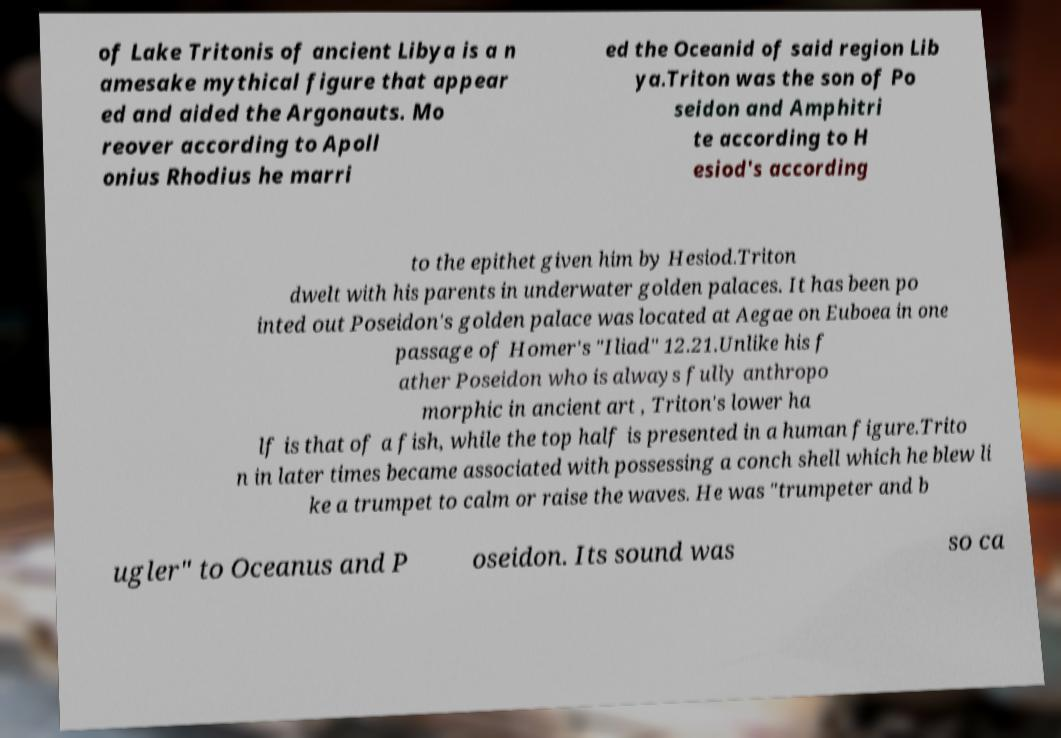Can you accurately transcribe the text from the provided image for me? of Lake Tritonis of ancient Libya is a n amesake mythical figure that appear ed and aided the Argonauts. Mo reover according to Apoll onius Rhodius he marri ed the Oceanid of said region Lib ya.Triton was the son of Po seidon and Amphitri te according to H esiod's according to the epithet given him by Hesiod.Triton dwelt with his parents in underwater golden palaces. It has been po inted out Poseidon's golden palace was located at Aegae on Euboea in one passage of Homer's "Iliad" 12.21.Unlike his f ather Poseidon who is always fully anthropo morphic in ancient art , Triton's lower ha lf is that of a fish, while the top half is presented in a human figure.Trito n in later times became associated with possessing a conch shell which he blew li ke a trumpet to calm or raise the waves. He was "trumpeter and b ugler" to Oceanus and P oseidon. Its sound was so ca 